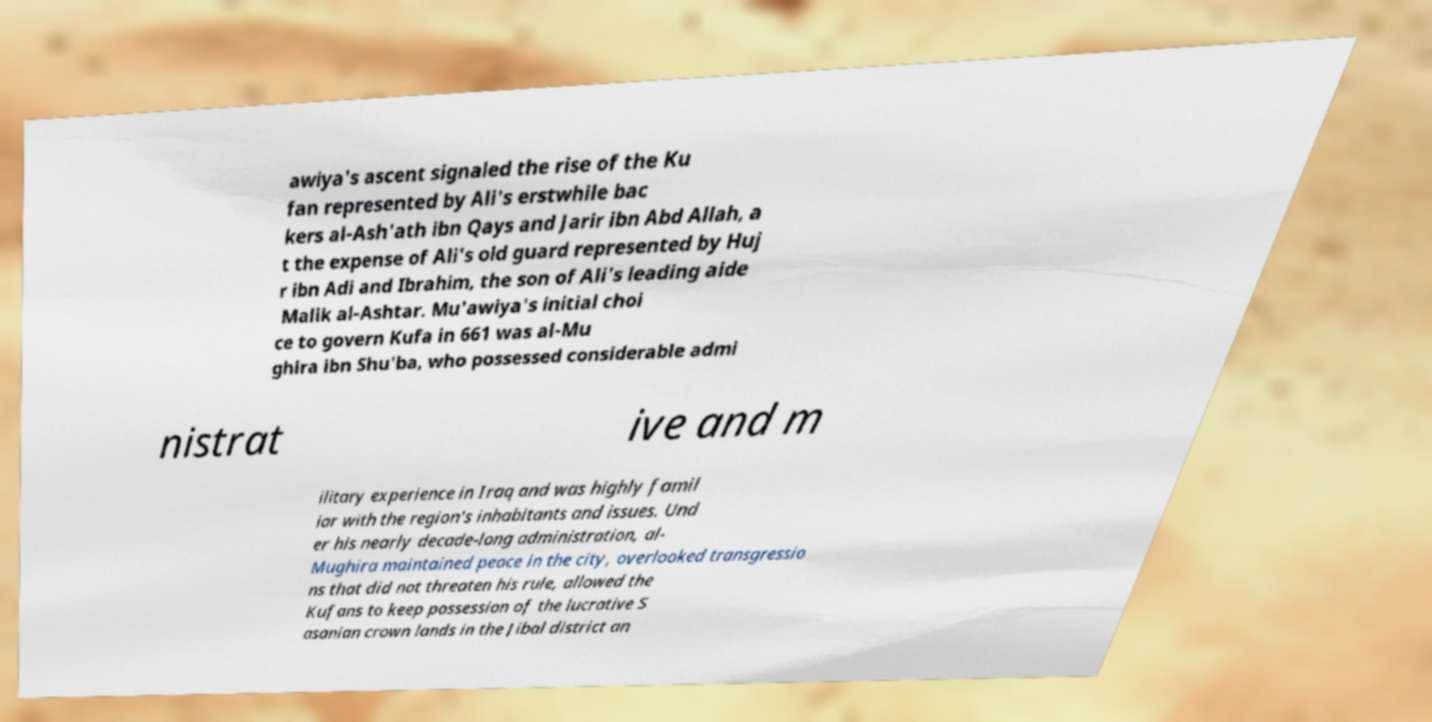Can you read and provide the text displayed in the image?This photo seems to have some interesting text. Can you extract and type it out for me? awiya's ascent signaled the rise of the Ku fan represented by Ali's erstwhile bac kers al-Ash'ath ibn Qays and Jarir ibn Abd Allah, a t the expense of Ali's old guard represented by Huj r ibn Adi and Ibrahim, the son of Ali's leading aide Malik al-Ashtar. Mu'awiya's initial choi ce to govern Kufa in 661 was al-Mu ghira ibn Shu'ba, who possessed considerable admi nistrat ive and m ilitary experience in Iraq and was highly famil iar with the region's inhabitants and issues. Und er his nearly decade-long administration, al- Mughira maintained peace in the city, overlooked transgressio ns that did not threaten his rule, allowed the Kufans to keep possession of the lucrative S asanian crown lands in the Jibal district an 